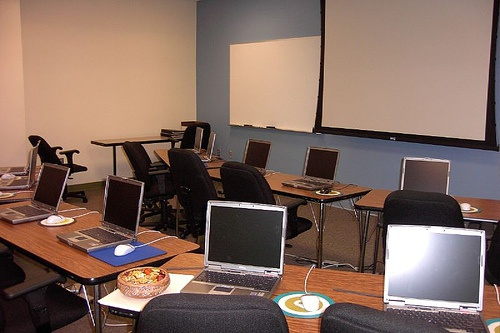Describe the objects in this image and their specific colors. I can see laptop in gray, white, black, and darkgray tones, laptop in gray, black, lightgray, and darkgray tones, chair in gray and black tones, chair in gray, black, maroon, and lavender tones, and laptop in gray, black, and maroon tones in this image. 